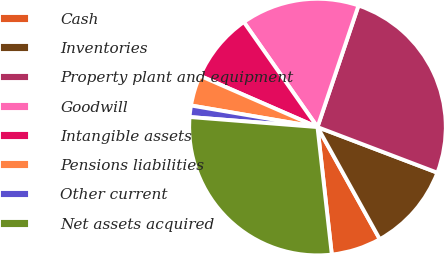Convert chart to OTSL. <chart><loc_0><loc_0><loc_500><loc_500><pie_chart><fcel>Cash<fcel>Inventories<fcel>Property plant and equipment<fcel>Goodwill<fcel>Intangible assets<fcel>Pensions liabilities<fcel>Other current<fcel>Net assets acquired<nl><fcel>6.29%<fcel>11.14%<fcel>25.61%<fcel>14.91%<fcel>8.72%<fcel>3.86%<fcel>1.44%<fcel>28.03%<nl></chart> 